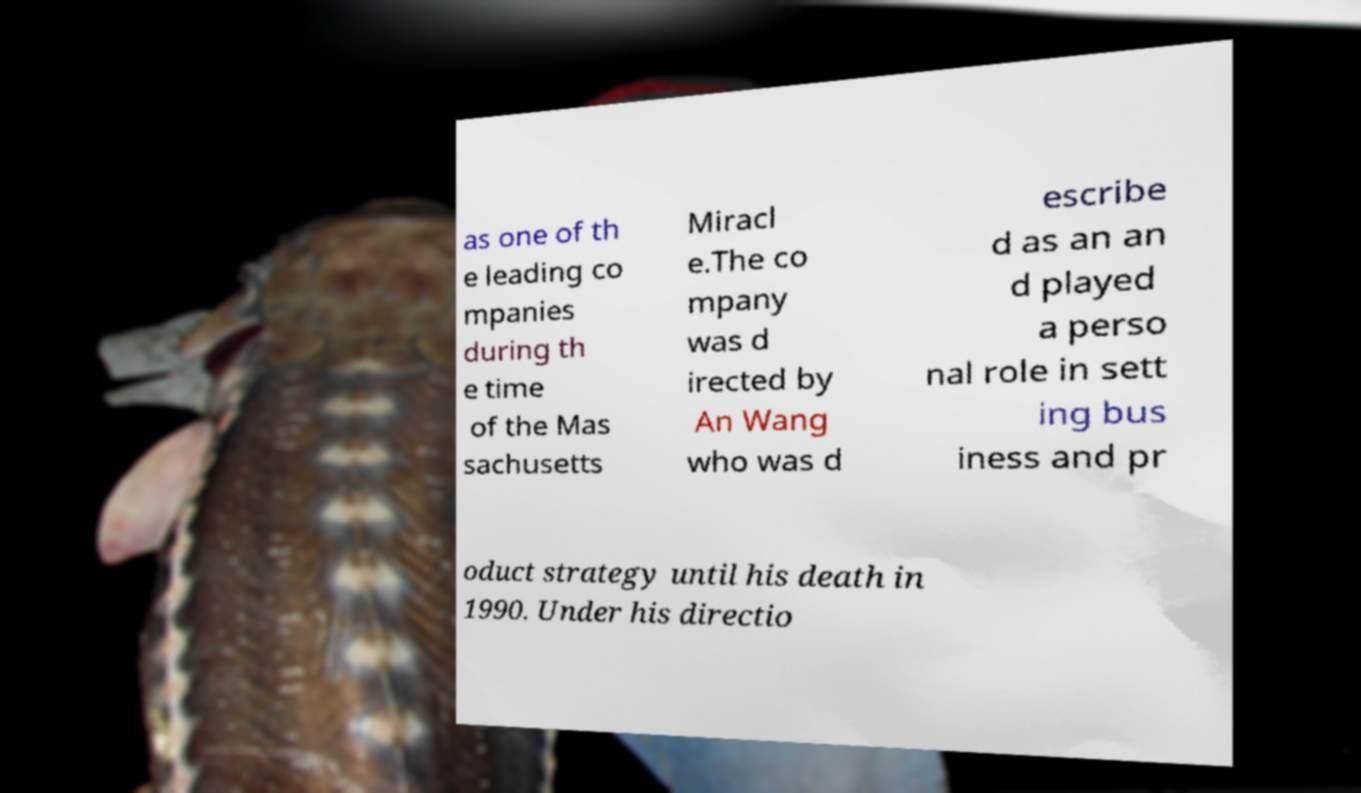Could you assist in decoding the text presented in this image and type it out clearly? as one of th e leading co mpanies during th e time of the Mas sachusetts Miracl e.The co mpany was d irected by An Wang who was d escribe d as an an d played a perso nal role in sett ing bus iness and pr oduct strategy until his death in 1990. Under his directio 